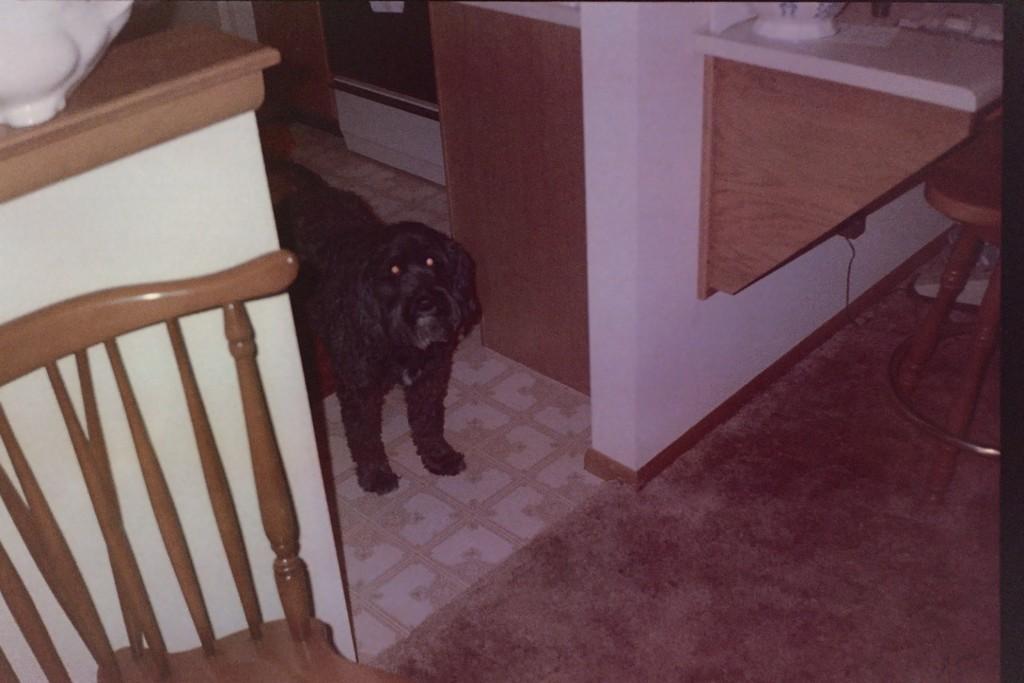Could you give a brief overview of what you see in this image? In this picture we can see a chair, dog. We can see objects on the racks. We can see the floor, carpet and few objects. 